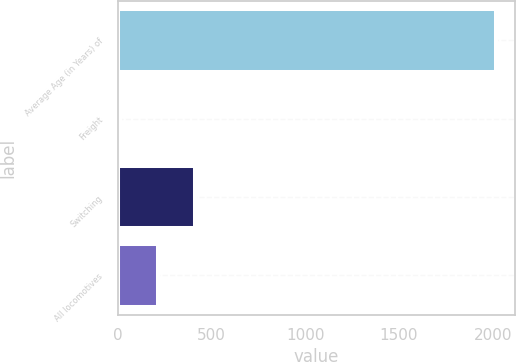Convert chart. <chart><loc_0><loc_0><loc_500><loc_500><bar_chart><fcel>Average Age (in Years) of<fcel>Freight<fcel>Switching<fcel>All locomotives<nl><fcel>2015<fcel>14<fcel>414.2<fcel>214.1<nl></chart> 